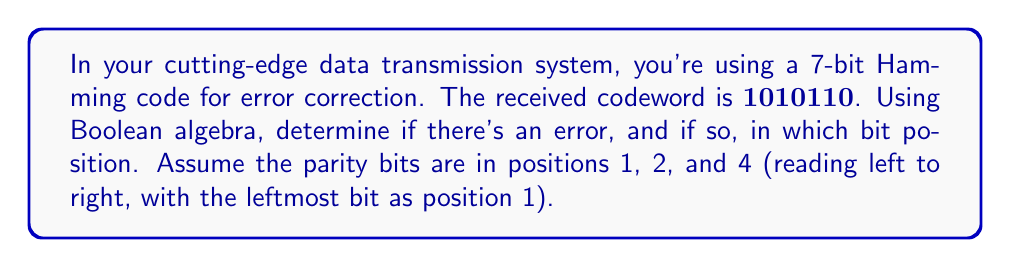Give your solution to this math problem. Let's approach this step-by-step using Boolean algebra:

1) In a 7-bit Hamming code, bits 1, 2, and 4 are parity bits. Let's call them $p_1$, $p_2$, and $p_4$. The data bits are in positions 3, 5, 6, and 7. Let's call them $d_3$, $d_5$, $d_6$, and $d_7$.

2) From the received codeword $1010110$, we have:
   $p_1 = 1$, $p_2 = 0$, $d_3 = 1$, $p_4 = 0$, $d_5 = 1$, $d_6 = 1$, $d_7 = 0$

3) In Hamming code, each parity bit checks specific bits:
   $p_1$ checks bits 1, 3, 5, 7
   $p_2$ checks bits 2, 3, 6, 7
   $p_4$ checks bits 4, 5, 6, 7

4) We need to check if these parity equations hold:
   $c_1: p_1 \oplus d_3 \oplus d_5 \oplus d_7 = 0$
   $c_2: p_2 \oplus d_3 \oplus d_6 \oplus d_7 = 0$
   $c_4: p_4 \oplus d_5 \oplus d_6 \oplus d_7 = 0$

   Where $\oplus$ represents XOR operation.

5) Let's calculate each:
   $c_1: 1 \oplus 1 \oplus 1 \oplus 0 = 1$
   $c_2: 0 \oplus 1 \oplus 1 \oplus 0 = 0$
   $c_4: 0 \oplus 1 \oplus 1 \oplus 0 = 0$

6) The error syndrome is $(c_1, c_2, c_4) = (1, 0, 0)$

7) In binary, $(1, 0, 0)$ represents the number 1.

Therefore, there is an error in bit position 1.
Answer: Error in bit position 1 